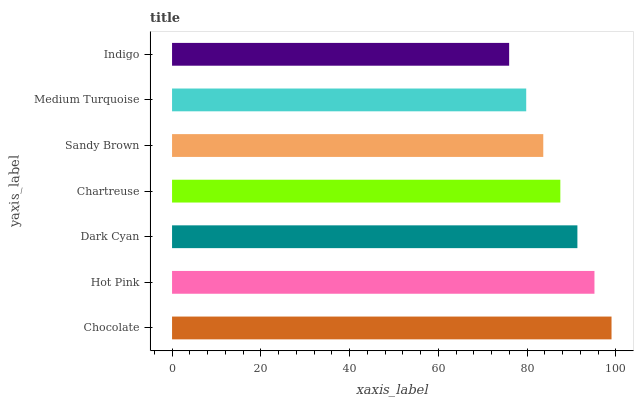Is Indigo the minimum?
Answer yes or no. Yes. Is Chocolate the maximum?
Answer yes or no. Yes. Is Hot Pink the minimum?
Answer yes or no. No. Is Hot Pink the maximum?
Answer yes or no. No. Is Chocolate greater than Hot Pink?
Answer yes or no. Yes. Is Hot Pink less than Chocolate?
Answer yes or no. Yes. Is Hot Pink greater than Chocolate?
Answer yes or no. No. Is Chocolate less than Hot Pink?
Answer yes or no. No. Is Chartreuse the high median?
Answer yes or no. Yes. Is Chartreuse the low median?
Answer yes or no. Yes. Is Sandy Brown the high median?
Answer yes or no. No. Is Sandy Brown the low median?
Answer yes or no. No. 